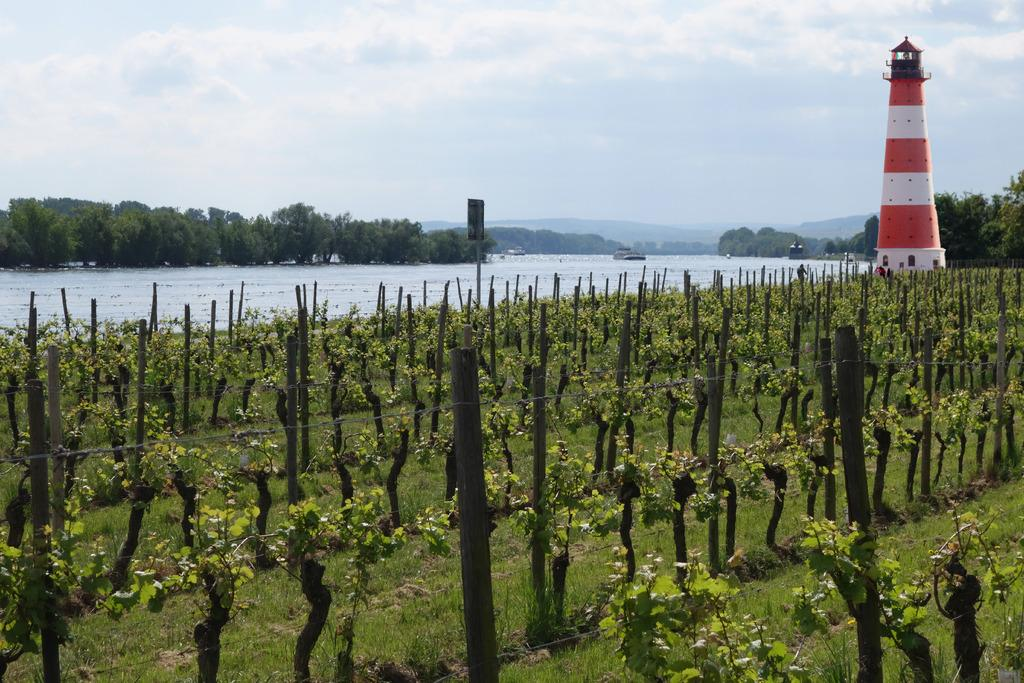What types of vegetation can be seen in the image? There are plants and trees in the image, and they are green. What can be seen in the background of the image? There is water visible in the background of the image. What structure is present in the image? There is a lighthouse in the image. What colors are used to the lighthouse? The lighthouse is white and orange. What is the color of the sky in the image? The sky is white in the image. Can you tell me how many balls the farmer is holding in the image? There is no farmer or balls present in the image. What type of sail is attached to the lighthouse in the image? There is no sail attached to the lighthouse in the image; it is a stationary structure. 